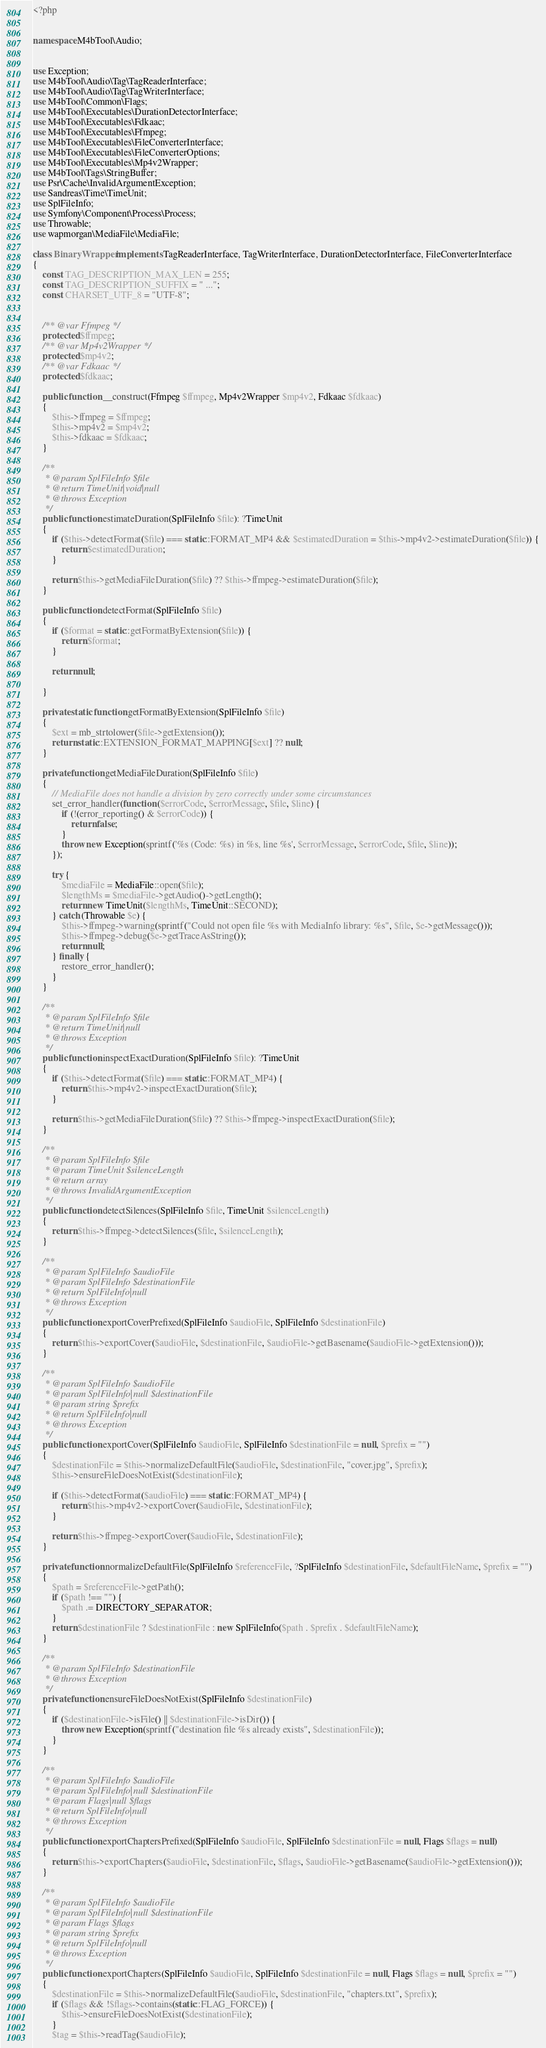Convert code to text. <code><loc_0><loc_0><loc_500><loc_500><_PHP_><?php


namespace M4bTool\Audio;


use Exception;
use M4bTool\Audio\Tag\TagReaderInterface;
use M4bTool\Audio\Tag\TagWriterInterface;
use M4bTool\Common\Flags;
use M4bTool\Executables\DurationDetectorInterface;
use M4bTool\Executables\Fdkaac;
use M4bTool\Executables\Ffmpeg;
use M4bTool\Executables\FileConverterInterface;
use M4bTool\Executables\FileConverterOptions;
use M4bTool\Executables\Mp4v2Wrapper;
use M4bTool\Tags\StringBuffer;
use Psr\Cache\InvalidArgumentException;
use Sandreas\Time\TimeUnit;
use SplFileInfo;
use Symfony\Component\Process\Process;
use Throwable;
use wapmorgan\MediaFile\MediaFile;

class BinaryWrapper implements TagReaderInterface, TagWriterInterface, DurationDetectorInterface, FileConverterInterface
{
    const TAG_DESCRIPTION_MAX_LEN = 255;
    const TAG_DESCRIPTION_SUFFIX = " ...";
    const CHARSET_UTF_8 = "UTF-8";


    /** @var Ffmpeg */
    protected $ffmpeg;
    /** @var Mp4v2Wrapper */
    protected $mp4v2;
    /** @var Fdkaac */
    protected $fdkaac;

    public function __construct(Ffmpeg $ffmpeg, Mp4v2Wrapper $mp4v2, Fdkaac $fdkaac)
    {
        $this->ffmpeg = $ffmpeg;
        $this->mp4v2 = $mp4v2;
        $this->fdkaac = $fdkaac;
    }

    /**
     * @param SplFileInfo $file
     * @return TimeUnit|void|null
     * @throws Exception
     */
    public function estimateDuration(SplFileInfo $file): ?TimeUnit
    {
        if ($this->detectFormat($file) === static::FORMAT_MP4 && $estimatedDuration = $this->mp4v2->estimateDuration($file)) {
            return $estimatedDuration;
        }

        return $this->getMediaFileDuration($file) ?? $this->ffmpeg->estimateDuration($file);
    }

    public function detectFormat(SplFileInfo $file)
    {
        if ($format = static::getFormatByExtension($file)) {
            return $format;
        }

        return null;

    }

    private static function getFormatByExtension(SplFileInfo $file)
    {
        $ext = mb_strtolower($file->getExtension());
        return static::EXTENSION_FORMAT_MAPPING[$ext] ?? null;
    }

    private function getMediaFileDuration(SplFileInfo $file)
    {
        // MediaFile does not handle a division by zero correctly under some circumstances
        set_error_handler(function ($errorCode, $errorMessage, $file, $line) {
            if (!(error_reporting() & $errorCode)) {
                return false;
            }
            throw new Exception(sprintf('%s (Code: %s) in %s, line %s', $errorMessage, $errorCode, $file, $line));
        });

        try {
            $mediaFile = MediaFile::open($file);
            $lengthMs = $mediaFile->getAudio()->getLength();
            return new TimeUnit($lengthMs, TimeUnit::SECOND);
        } catch (Throwable $e) {
            $this->ffmpeg->warning(sprintf("Could not open file %s with MediaInfo library: %s", $file, $e->getMessage()));
            $this->ffmpeg->debug($e->getTraceAsString());
            return null;
        } finally {
            restore_error_handler();
        }
    }

    /**
     * @param SplFileInfo $file
     * @return TimeUnit|null
     * @throws Exception
     */
    public function inspectExactDuration(SplFileInfo $file): ?TimeUnit
    {
        if ($this->detectFormat($file) === static::FORMAT_MP4) {
            return $this->mp4v2->inspectExactDuration($file);
        }

        return $this->getMediaFileDuration($file) ?? $this->ffmpeg->inspectExactDuration($file);
    }

    /**
     * @param SplFileInfo $file
     * @param TimeUnit $silenceLength
     * @return array
     * @throws InvalidArgumentException
     */
    public function detectSilences(SplFileInfo $file, TimeUnit $silenceLength)
    {
        return $this->ffmpeg->detectSilences($file, $silenceLength);
    }

    /**
     * @param SplFileInfo $audioFile
     * @param SplFileInfo $destinationFile
     * @return SplFileInfo|null
     * @throws Exception
     */
    public function exportCoverPrefixed(SplFileInfo $audioFile, SplFileInfo $destinationFile)
    {
        return $this->exportCover($audioFile, $destinationFile, $audioFile->getBasename($audioFile->getExtension()));
    }

    /**
     * @param SplFileInfo $audioFile
     * @param SplFileInfo|null $destinationFile
     * @param string $prefix
     * @return SplFileInfo|null
     * @throws Exception
     */
    public function exportCover(SplFileInfo $audioFile, SplFileInfo $destinationFile = null, $prefix = "")
    {
        $destinationFile = $this->normalizeDefaultFile($audioFile, $destinationFile, "cover.jpg", $prefix);
        $this->ensureFileDoesNotExist($destinationFile);

        if ($this->detectFormat($audioFile) === static::FORMAT_MP4) {
            return $this->mp4v2->exportCover($audioFile, $destinationFile);
        }

        return $this->ffmpeg->exportCover($audioFile, $destinationFile);
    }

    private function normalizeDefaultFile(SplFileInfo $referenceFile, ?SplFileInfo $destinationFile, $defaultFileName, $prefix = "")
    {
        $path = $referenceFile->getPath();
        if ($path !== "") {
            $path .= DIRECTORY_SEPARATOR;
        }
        return $destinationFile ? $destinationFile : new SplFileInfo($path . $prefix . $defaultFileName);
    }

    /**
     * @param SplFileInfo $destinationFile
     * @throws Exception
     */
    private function ensureFileDoesNotExist(SplFileInfo $destinationFile)
    {
        if ($destinationFile->isFile() || $destinationFile->isDir()) {
            throw new Exception(sprintf("destination file %s already exists", $destinationFile));
        }
    }

    /**
     * @param SplFileInfo $audioFile
     * @param SplFileInfo|null $destinationFile
     * @param Flags|null $flags
     * @return SplFileInfo|null
     * @throws Exception
     */
    public function exportChaptersPrefixed(SplFileInfo $audioFile, SplFileInfo $destinationFile = null, Flags $flags = null)
    {
        return $this->exportChapters($audioFile, $destinationFile, $flags, $audioFile->getBasename($audioFile->getExtension()));
    }

    /**
     * @param SplFileInfo $audioFile
     * @param SplFileInfo|null $destinationFile
     * @param Flags $flags
     * @param string $prefix
     * @return SplFileInfo|null
     * @throws Exception
     */
    public function exportChapters(SplFileInfo $audioFile, SplFileInfo $destinationFile = null, Flags $flags = null, $prefix = "")
    {
        $destinationFile = $this->normalizeDefaultFile($audioFile, $destinationFile, "chapters.txt", $prefix);
        if ($flags && !$flags->contains(static::FLAG_FORCE)) {
            $this->ensureFileDoesNotExist($destinationFile);
        }
        $tag = $this->readTag($audioFile);</code> 